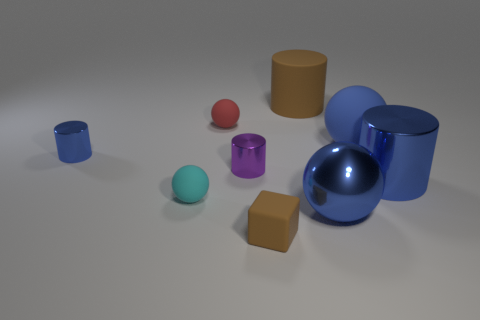What is the size of the matte sphere that is the same color as the metallic ball?
Your answer should be very brief. Large. Does the big ball that is behind the big blue cylinder have the same color as the shiny ball?
Give a very brief answer. Yes. How many rubber balls are on the right side of the brown rubber thing that is behind the brown rubber object in front of the big blue matte sphere?
Your answer should be very brief. 1. What number of large cylinders are to the left of the big matte ball and on the right side of the large rubber cylinder?
Keep it short and to the point. 0. There is a big object that is the same color as the small cube; what is its shape?
Your response must be concise. Cylinder. Do the tiny red thing and the small cyan sphere have the same material?
Offer a very short reply. Yes. There is a tiny thing behind the blue metal thing that is on the left side of the brown rubber object in front of the large blue metallic sphere; what shape is it?
Your response must be concise. Sphere. Are there fewer small cyan matte spheres that are left of the large blue metallic ball than matte spheres that are in front of the purple metallic thing?
Ensure brevity in your answer.  No. What is the shape of the blue object to the left of the large blue metallic thing that is in front of the cyan object?
Give a very brief answer. Cylinder. Is there anything else that is the same color as the large rubber cylinder?
Provide a short and direct response. Yes. 